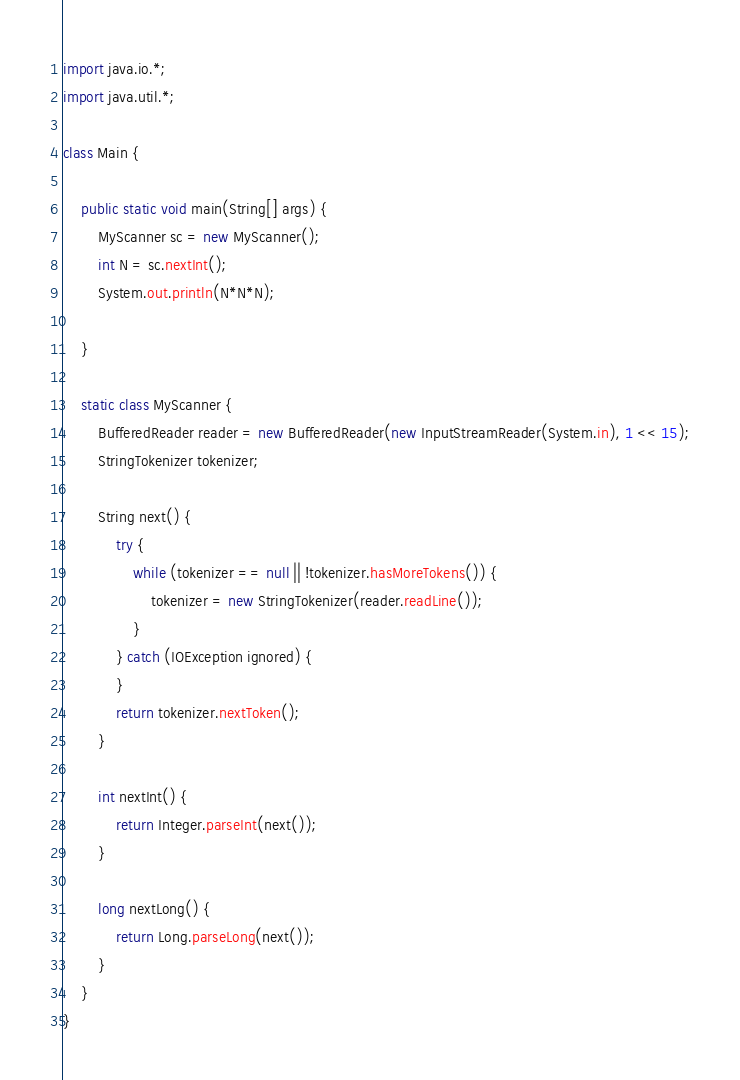Convert code to text. <code><loc_0><loc_0><loc_500><loc_500><_Java_>import java.io.*;
import java.util.*;

class Main {

    public static void main(String[] args) {
        MyScanner sc = new MyScanner();
        int N = sc.nextInt();
        System.out.println(N*N*N);

    }

    static class MyScanner {
        BufferedReader reader = new BufferedReader(new InputStreamReader(System.in), 1 << 15);
        StringTokenizer tokenizer;
    
        String next() {
            try {
                while (tokenizer == null || !tokenizer.hasMoreTokens()) {
                    tokenizer = new StringTokenizer(reader.readLine());
                }
            } catch (IOException ignored) {
            }
            return tokenizer.nextToken();
        }
    
        int nextInt() {
            return Integer.parseInt(next());
        }
    
        long nextLong() {
            return Long.parseLong(next());
        }
    }
}</code> 